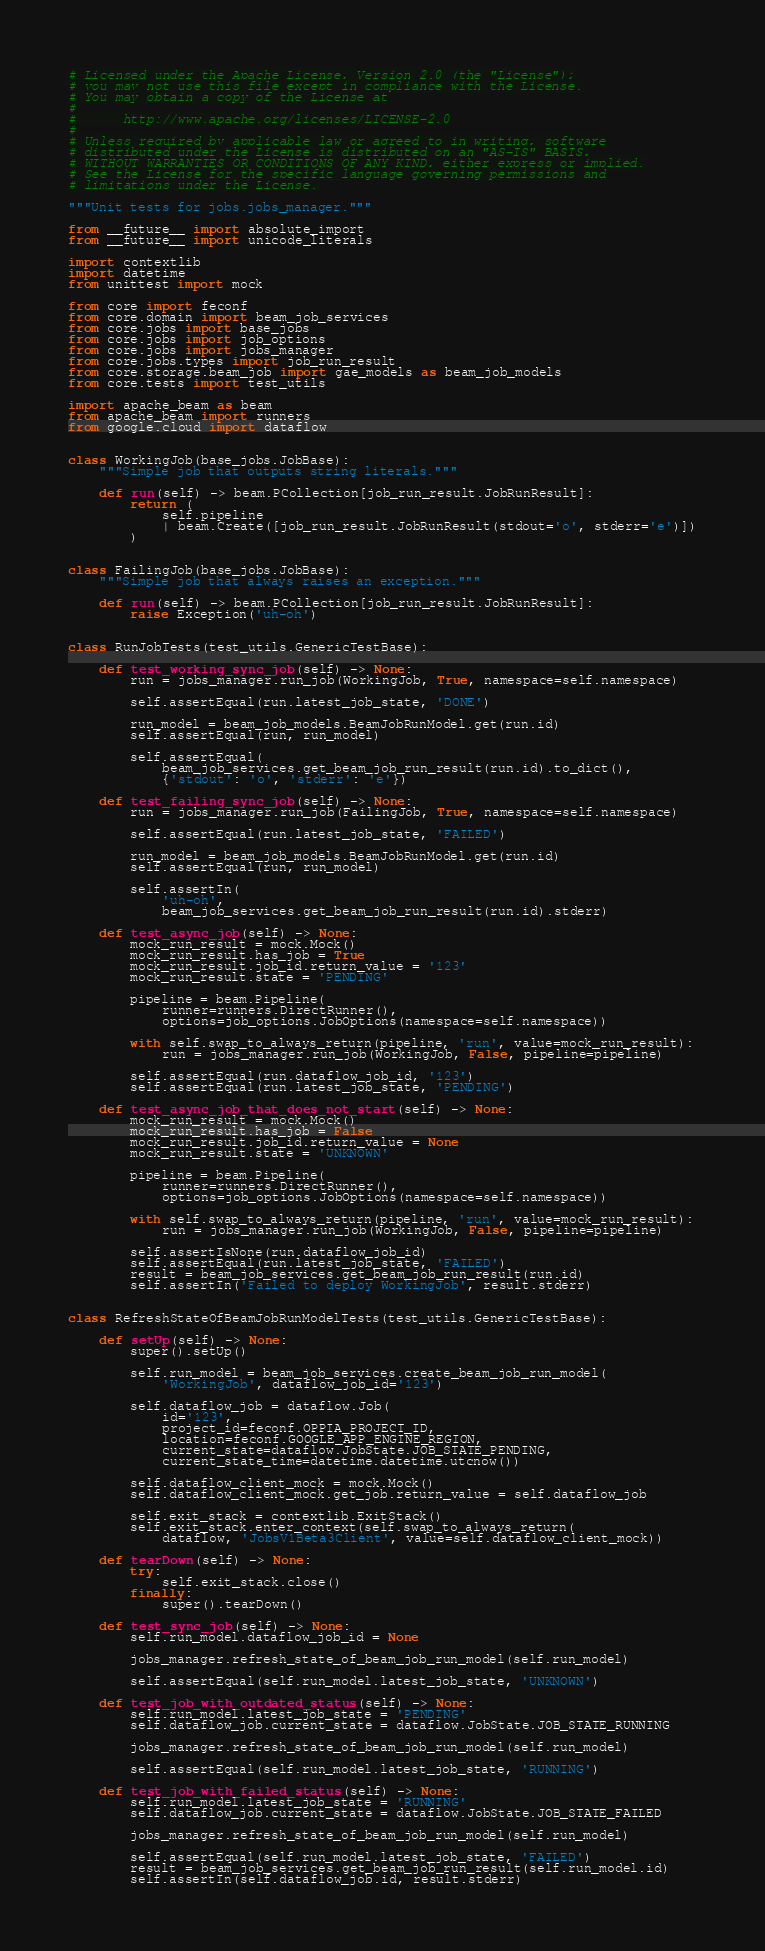Convert code to text. <code><loc_0><loc_0><loc_500><loc_500><_Python_># Licensed under the Apache License, Version 2.0 (the "License");
# you may not use this file except in compliance with the License.
# You may obtain a copy of the License at
#
#      http://www.apache.org/licenses/LICENSE-2.0
#
# Unless required by applicable law or agreed to in writing, software
# distributed under the License is distributed on an "AS-IS" BASIS,
# WITHOUT WARRANTIES OR CONDITIONS OF ANY KIND, either express or implied.
# See the License for the specific language governing permissions and
# limitations under the License.

"""Unit tests for jobs.jobs_manager."""

from __future__ import absolute_import
from __future__ import unicode_literals

import contextlib
import datetime
from unittest import mock

from core import feconf
from core.domain import beam_job_services
from core.jobs import base_jobs
from core.jobs import job_options
from core.jobs import jobs_manager
from core.jobs.types import job_run_result
from core.storage.beam_job import gae_models as beam_job_models
from core.tests import test_utils

import apache_beam as beam
from apache_beam import runners
from google.cloud import dataflow


class WorkingJob(base_jobs.JobBase):
    """Simple job that outputs string literals."""

    def run(self) -> beam.PCollection[job_run_result.JobRunResult]:
        return (
            self.pipeline
            | beam.Create([job_run_result.JobRunResult(stdout='o', stderr='e')])
        )


class FailingJob(base_jobs.JobBase):
    """Simple job that always raises an exception."""

    def run(self) -> beam.PCollection[job_run_result.JobRunResult]:
        raise Exception('uh-oh')


class RunJobTests(test_utils.GenericTestBase):

    def test_working_sync_job(self) -> None:
        run = jobs_manager.run_job(WorkingJob, True, namespace=self.namespace)

        self.assertEqual(run.latest_job_state, 'DONE')

        run_model = beam_job_models.BeamJobRunModel.get(run.id)
        self.assertEqual(run, run_model)

        self.assertEqual(
            beam_job_services.get_beam_job_run_result(run.id).to_dict(),
            {'stdout': 'o', 'stderr': 'e'})

    def test_failing_sync_job(self) -> None:
        run = jobs_manager.run_job(FailingJob, True, namespace=self.namespace)

        self.assertEqual(run.latest_job_state, 'FAILED')

        run_model = beam_job_models.BeamJobRunModel.get(run.id)
        self.assertEqual(run, run_model)

        self.assertIn(
            'uh-oh',
            beam_job_services.get_beam_job_run_result(run.id).stderr)

    def test_async_job(self) -> None:
        mock_run_result = mock.Mock()
        mock_run_result.has_job = True
        mock_run_result.job_id.return_value = '123'
        mock_run_result.state = 'PENDING'

        pipeline = beam.Pipeline(
            runner=runners.DirectRunner(),
            options=job_options.JobOptions(namespace=self.namespace))

        with self.swap_to_always_return(pipeline, 'run', value=mock_run_result):
            run = jobs_manager.run_job(WorkingJob, False, pipeline=pipeline)

        self.assertEqual(run.dataflow_job_id, '123')
        self.assertEqual(run.latest_job_state, 'PENDING')

    def test_async_job_that_does_not_start(self) -> None:
        mock_run_result = mock.Mock()
        mock_run_result.has_job = False
        mock_run_result.job_id.return_value = None
        mock_run_result.state = 'UNKNOWN'

        pipeline = beam.Pipeline(
            runner=runners.DirectRunner(),
            options=job_options.JobOptions(namespace=self.namespace))

        with self.swap_to_always_return(pipeline, 'run', value=mock_run_result):
            run = jobs_manager.run_job(WorkingJob, False, pipeline=pipeline)

        self.assertIsNone(run.dataflow_job_id)
        self.assertEqual(run.latest_job_state, 'FAILED')
        result = beam_job_services.get_beam_job_run_result(run.id)
        self.assertIn('Failed to deploy WorkingJob', result.stderr)


class RefreshStateOfBeamJobRunModelTests(test_utils.GenericTestBase):

    def setUp(self) -> None:
        super().setUp()

        self.run_model = beam_job_services.create_beam_job_run_model(
            'WorkingJob', dataflow_job_id='123')

        self.dataflow_job = dataflow.Job(
            id='123',
            project_id=feconf.OPPIA_PROJECT_ID,
            location=feconf.GOOGLE_APP_ENGINE_REGION,
            current_state=dataflow.JobState.JOB_STATE_PENDING,
            current_state_time=datetime.datetime.utcnow())

        self.dataflow_client_mock = mock.Mock()
        self.dataflow_client_mock.get_job.return_value = self.dataflow_job

        self.exit_stack = contextlib.ExitStack()
        self.exit_stack.enter_context(self.swap_to_always_return(
            dataflow, 'JobsV1Beta3Client', value=self.dataflow_client_mock))

    def tearDown(self) -> None:
        try:
            self.exit_stack.close()
        finally:
            super().tearDown()

    def test_sync_job(self) -> None:
        self.run_model.dataflow_job_id = None

        jobs_manager.refresh_state_of_beam_job_run_model(self.run_model)

        self.assertEqual(self.run_model.latest_job_state, 'UNKNOWN')

    def test_job_with_outdated_status(self) -> None:
        self.run_model.latest_job_state = 'PENDING'
        self.dataflow_job.current_state = dataflow.JobState.JOB_STATE_RUNNING

        jobs_manager.refresh_state_of_beam_job_run_model(self.run_model)

        self.assertEqual(self.run_model.latest_job_state, 'RUNNING')

    def test_job_with_failed_status(self) -> None:
        self.run_model.latest_job_state = 'RUNNING'
        self.dataflow_job.current_state = dataflow.JobState.JOB_STATE_FAILED

        jobs_manager.refresh_state_of_beam_job_run_model(self.run_model)

        self.assertEqual(self.run_model.latest_job_state, 'FAILED')
        result = beam_job_services.get_beam_job_run_result(self.run_model.id)
        self.assertIn(self.dataflow_job.id, result.stderr)
</code> 